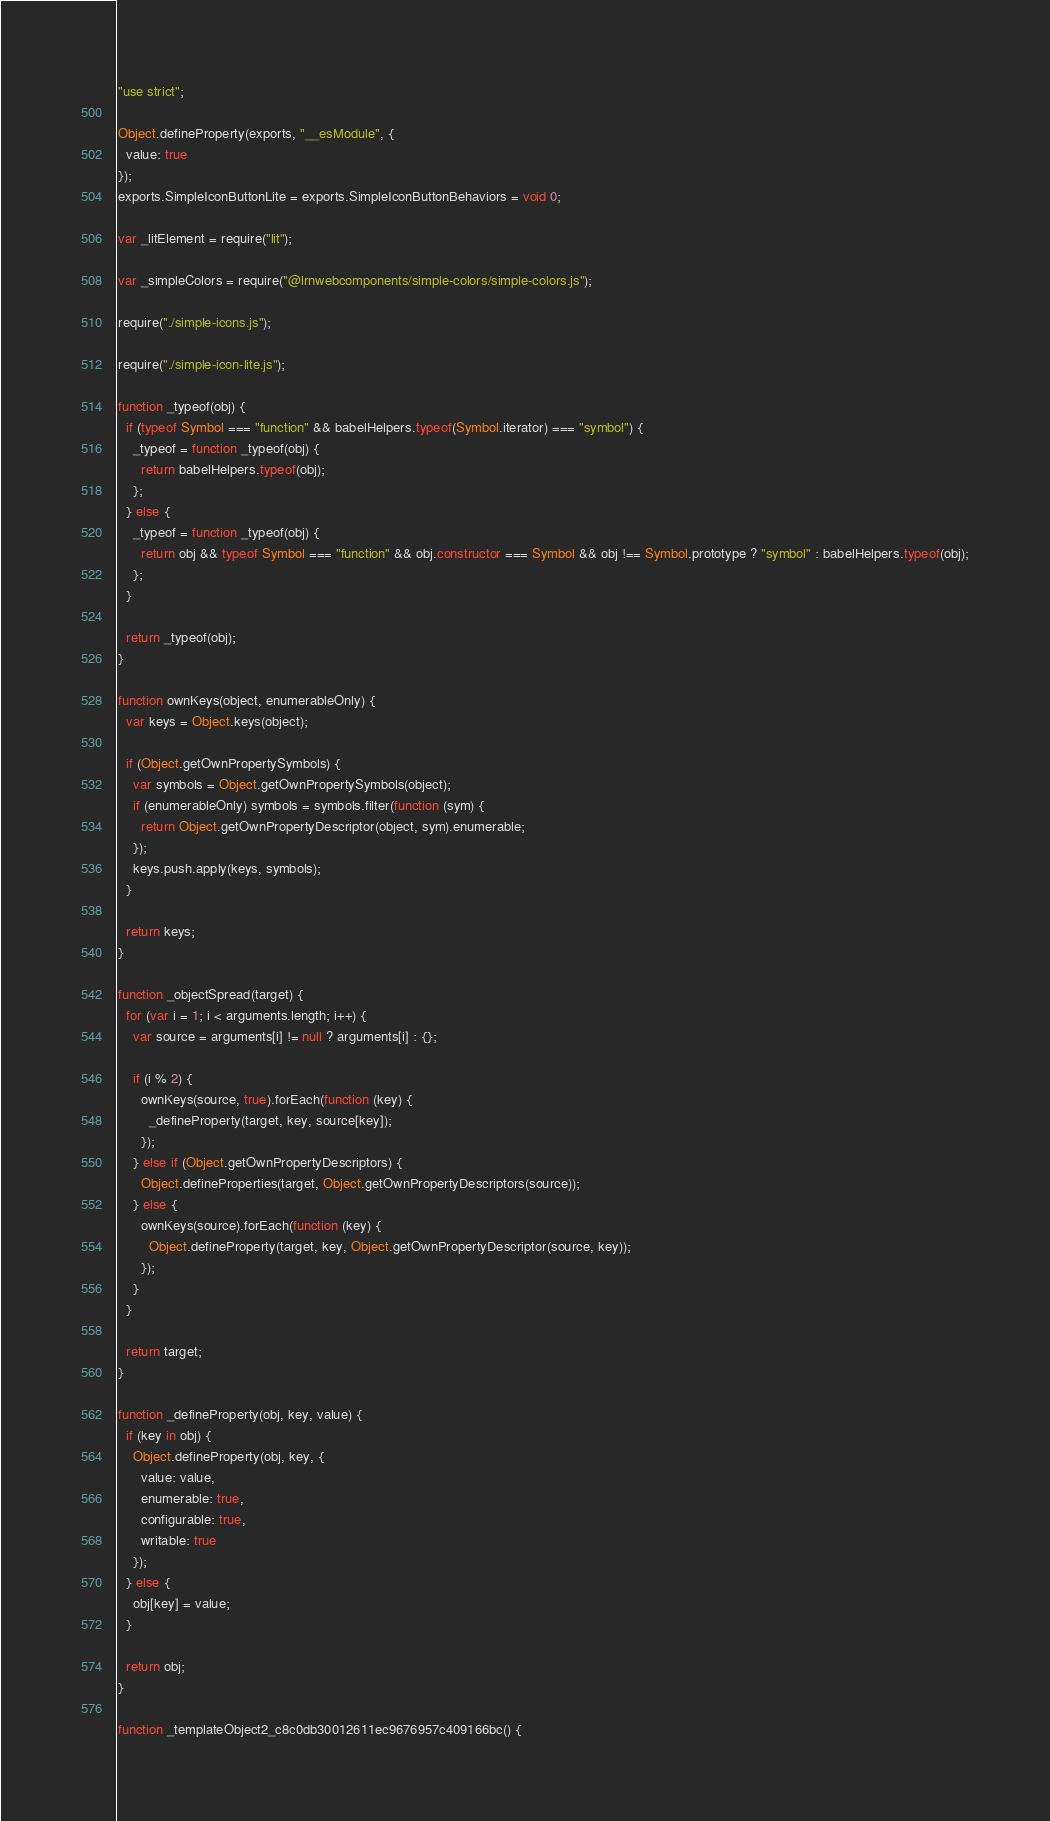Convert code to text. <code><loc_0><loc_0><loc_500><loc_500><_JavaScript_>"use strict";

Object.defineProperty(exports, "__esModule", {
  value: true
});
exports.SimpleIconButtonLite = exports.SimpleIconButtonBehaviors = void 0;

var _litElement = require("lit");

var _simpleColors = require("@lrnwebcomponents/simple-colors/simple-colors.js");

require("./simple-icons.js");

require("./simple-icon-lite.js");

function _typeof(obj) {
  if (typeof Symbol === "function" && babelHelpers.typeof(Symbol.iterator) === "symbol") {
    _typeof = function _typeof(obj) {
      return babelHelpers.typeof(obj);
    };
  } else {
    _typeof = function _typeof(obj) {
      return obj && typeof Symbol === "function" && obj.constructor === Symbol && obj !== Symbol.prototype ? "symbol" : babelHelpers.typeof(obj);
    };
  }

  return _typeof(obj);
}

function ownKeys(object, enumerableOnly) {
  var keys = Object.keys(object);

  if (Object.getOwnPropertySymbols) {
    var symbols = Object.getOwnPropertySymbols(object);
    if (enumerableOnly) symbols = symbols.filter(function (sym) {
      return Object.getOwnPropertyDescriptor(object, sym).enumerable;
    });
    keys.push.apply(keys, symbols);
  }

  return keys;
}

function _objectSpread(target) {
  for (var i = 1; i < arguments.length; i++) {
    var source = arguments[i] != null ? arguments[i] : {};

    if (i % 2) {
      ownKeys(source, true).forEach(function (key) {
        _defineProperty(target, key, source[key]);
      });
    } else if (Object.getOwnPropertyDescriptors) {
      Object.defineProperties(target, Object.getOwnPropertyDescriptors(source));
    } else {
      ownKeys(source).forEach(function (key) {
        Object.defineProperty(target, key, Object.getOwnPropertyDescriptor(source, key));
      });
    }
  }

  return target;
}

function _defineProperty(obj, key, value) {
  if (key in obj) {
    Object.defineProperty(obj, key, {
      value: value,
      enumerable: true,
      configurable: true,
      writable: true
    });
  } else {
    obj[key] = value;
  }

  return obj;
}

function _templateObject2_c8c0db30012611ec9676957c409166bc() {</code> 